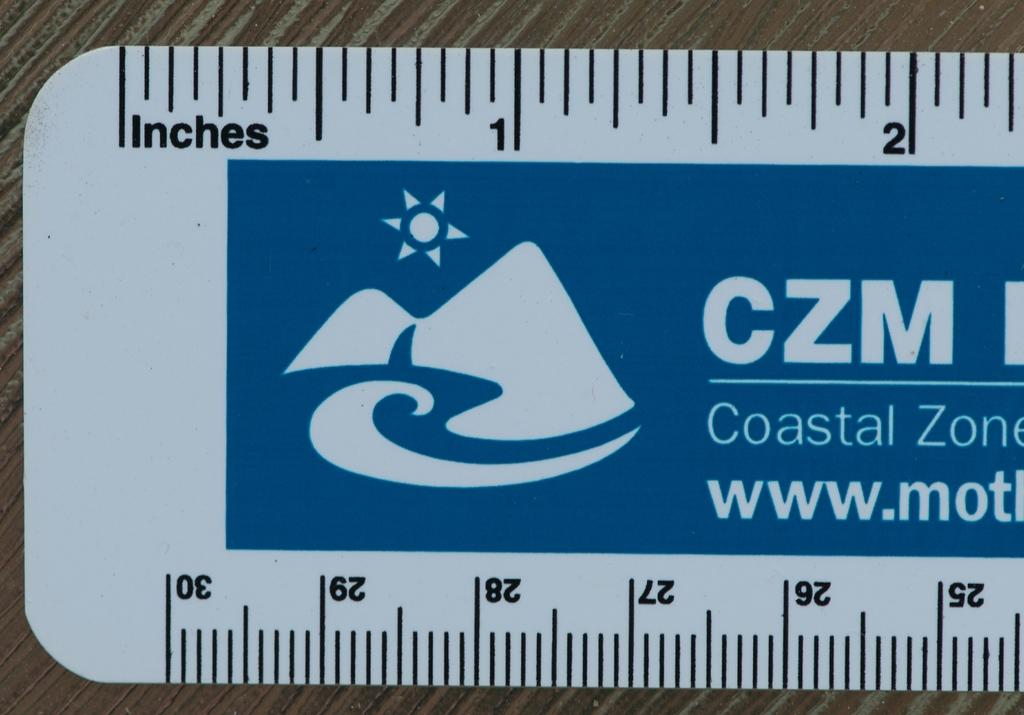<image>
Render a clear and concise summary of the photo. a rulers in inches and centimeters from the coastal zone 